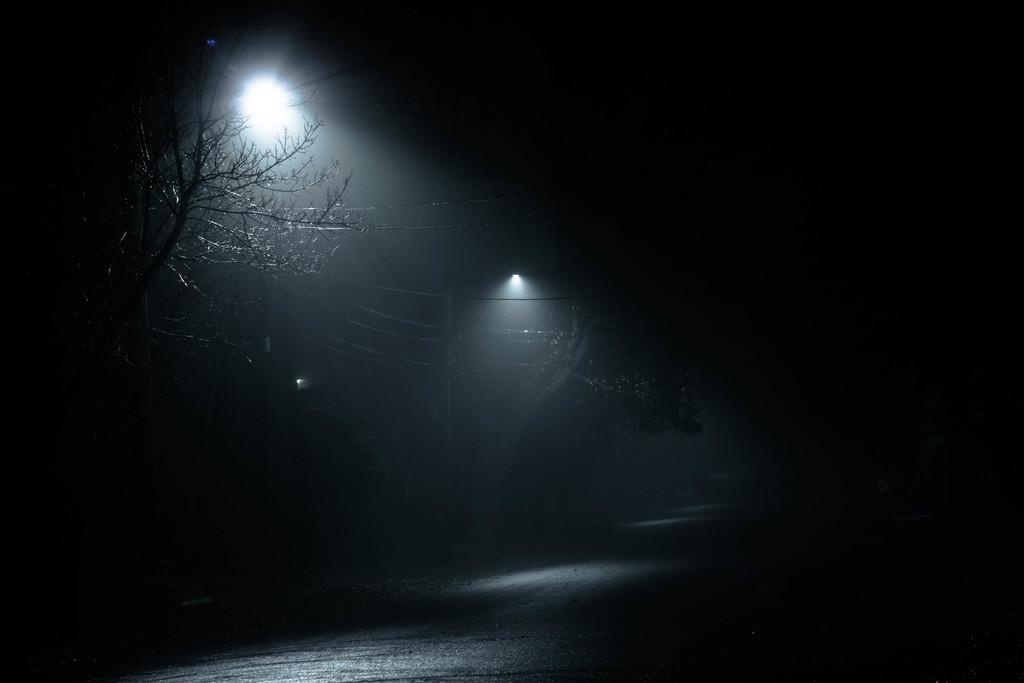Please provide a concise description of this image. I see this image is dark and I see the lights and I see a pole over here and I see the wires and I see the trees. 